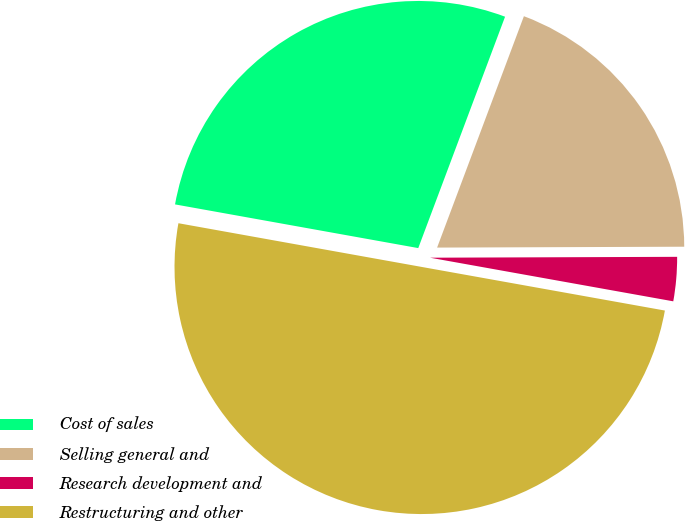<chart> <loc_0><loc_0><loc_500><loc_500><pie_chart><fcel>Cost of sales<fcel>Selling general and<fcel>Research development and<fcel>Restructuring and other<nl><fcel>27.88%<fcel>19.23%<fcel>2.88%<fcel>50.0%<nl></chart> 